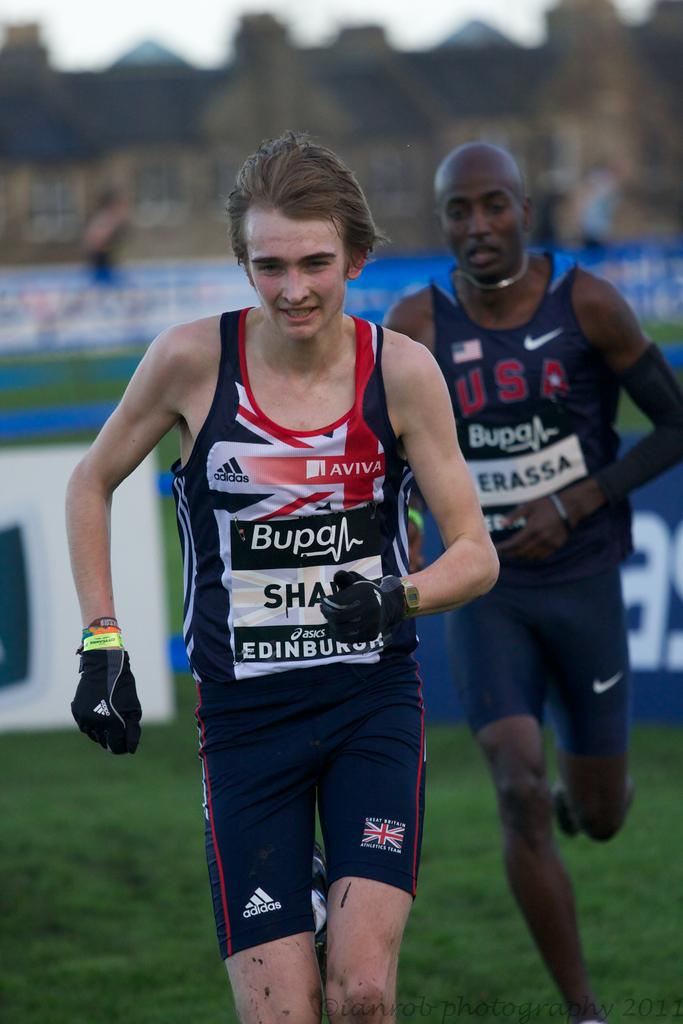<image>
Write a terse but informative summary of the picture. a man with erassa on his outfit with a person running in front of them 